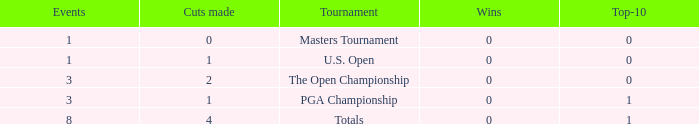For events with values of exactly 1, and 0 cuts made, what is the fewest number of top-10s? 0.0. 